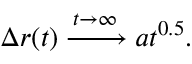<formula> <loc_0><loc_0><loc_500><loc_500>\Delta r ( t ) \xrightarrow { t \rightarrow \infty } a t ^ { 0 . 5 } .</formula> 